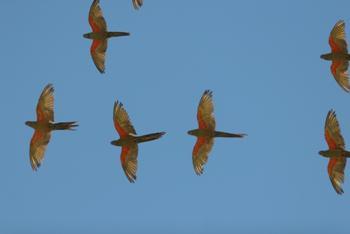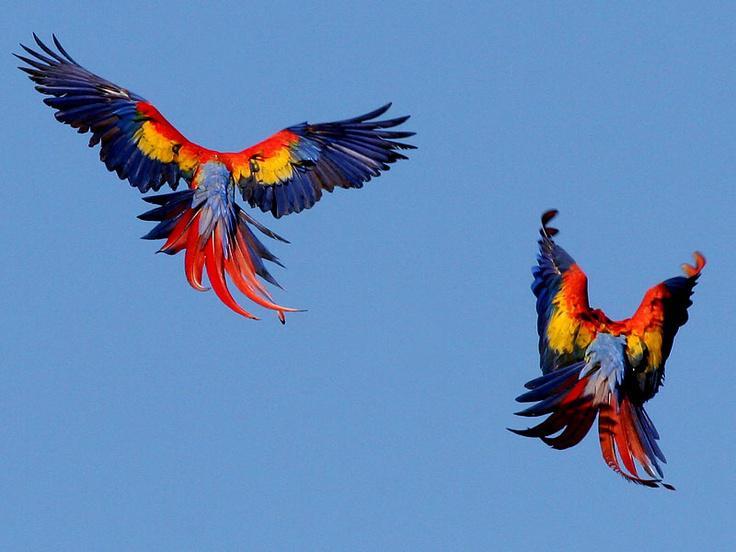The first image is the image on the left, the second image is the image on the right. For the images displayed, is the sentence "There are 4 or more parrots flying to the right." factually correct? Answer yes or no. No. 